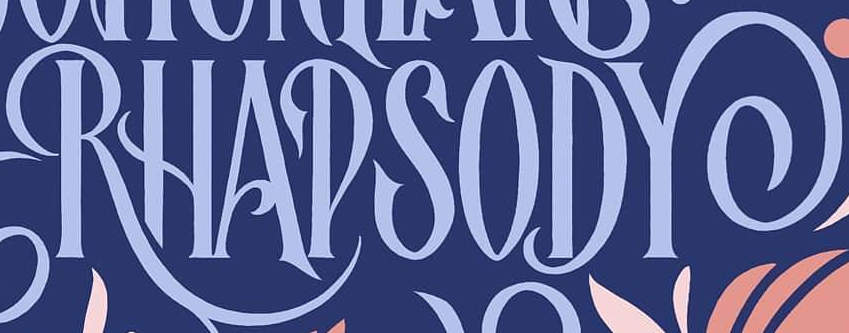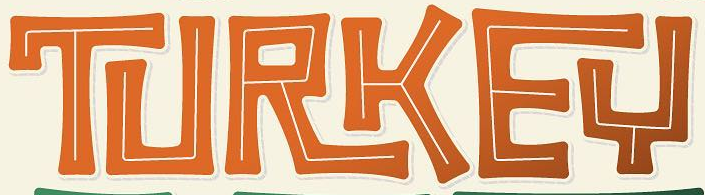Read the text content from these images in order, separated by a semicolon. RHAPSODY; TURKEY 